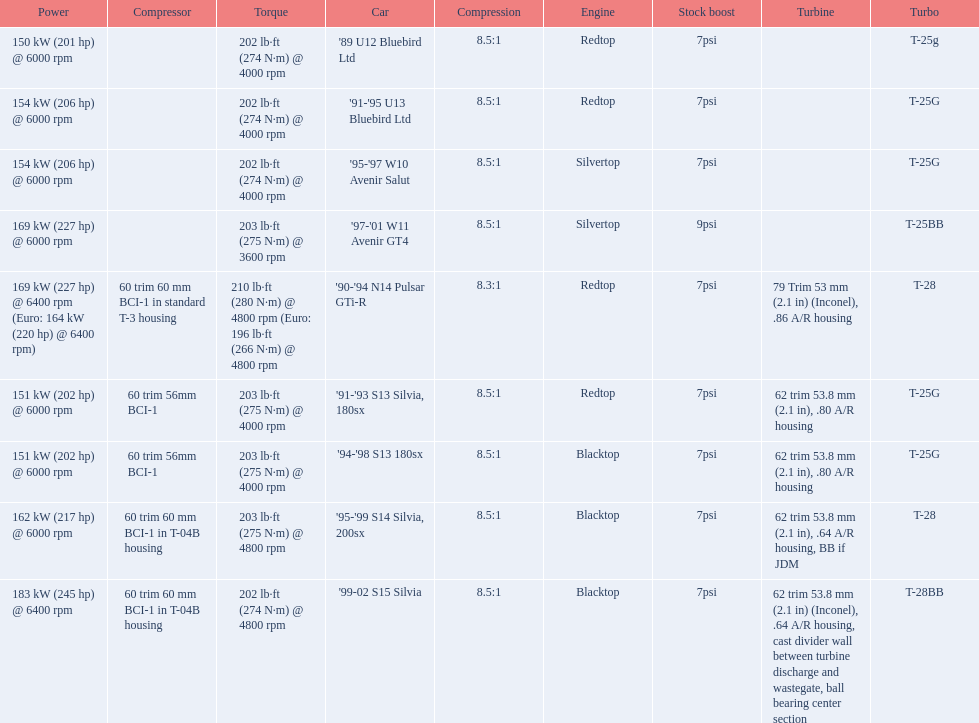What are the psi's? 7psi, 7psi, 7psi, 9psi, 7psi, 7psi, 7psi, 7psi, 7psi. What are the number(s) greater than 7? 9psi. Which car has that number? '97-'01 W11 Avenir GT4. 